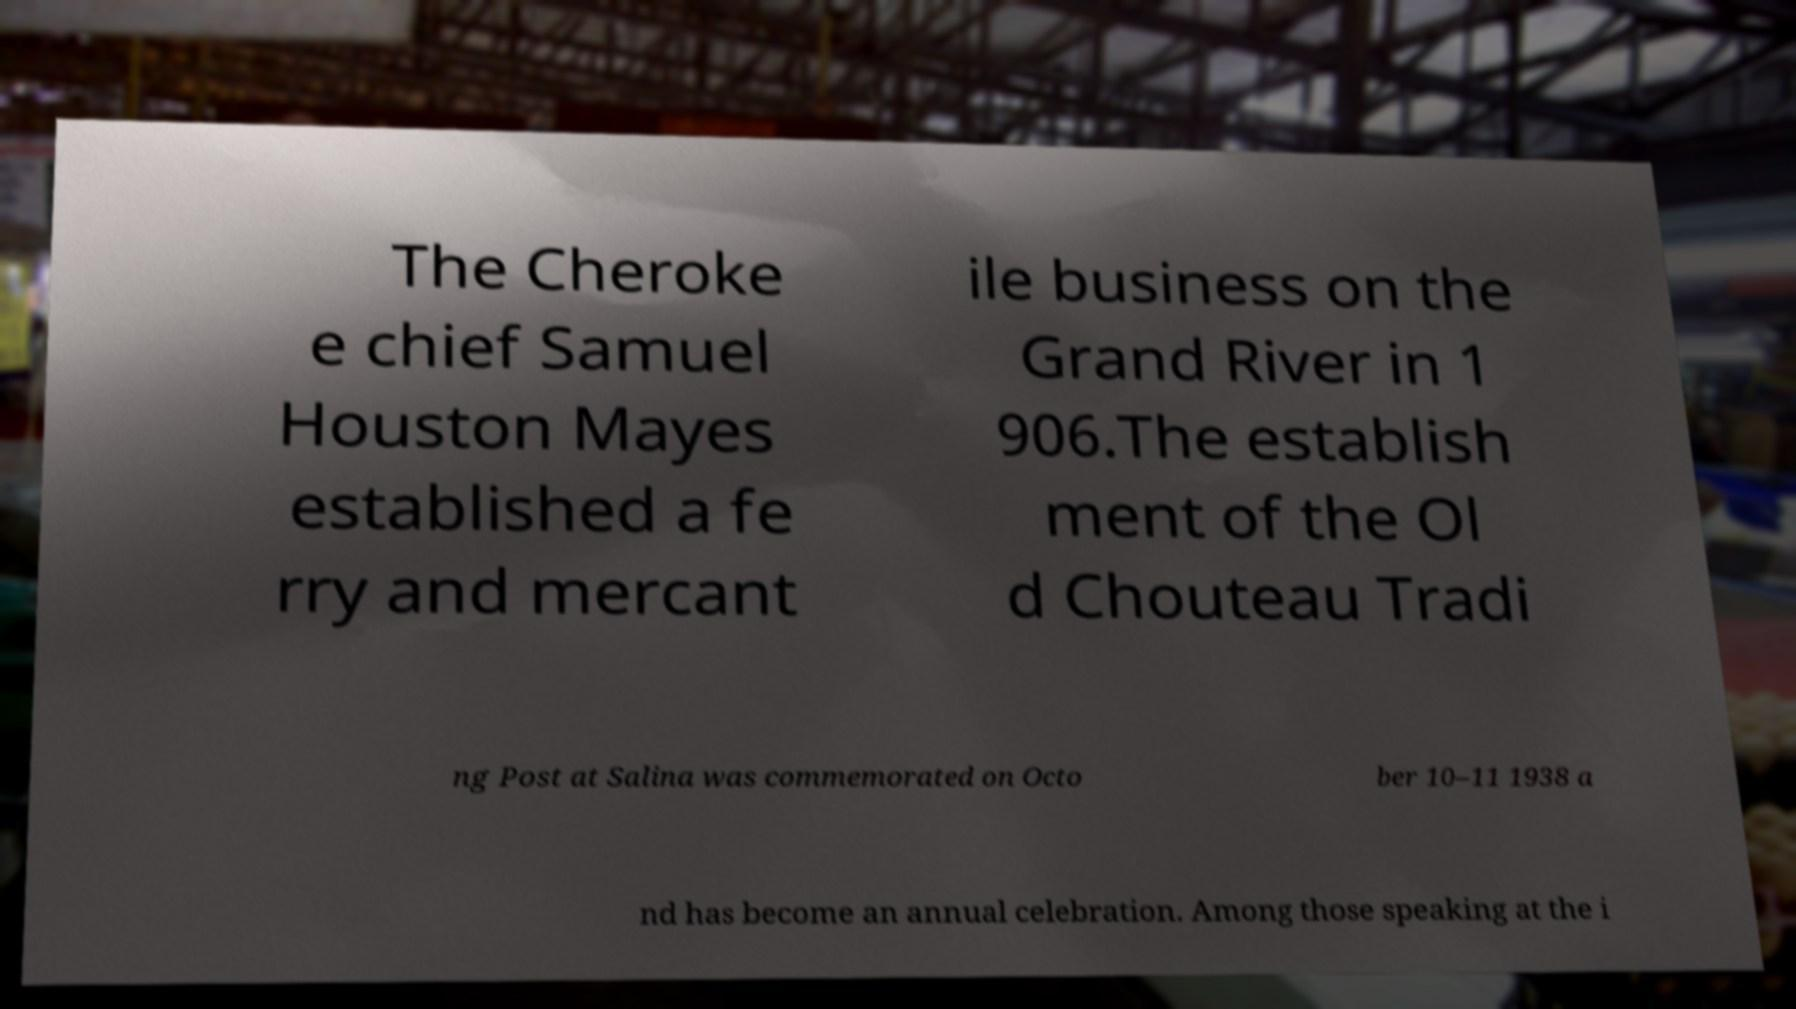Could you extract and type out the text from this image? The Cheroke e chief Samuel Houston Mayes established a fe rry and mercant ile business on the Grand River in 1 906.The establish ment of the Ol d Chouteau Tradi ng Post at Salina was commemorated on Octo ber 10–11 1938 a nd has become an annual celebration. Among those speaking at the i 